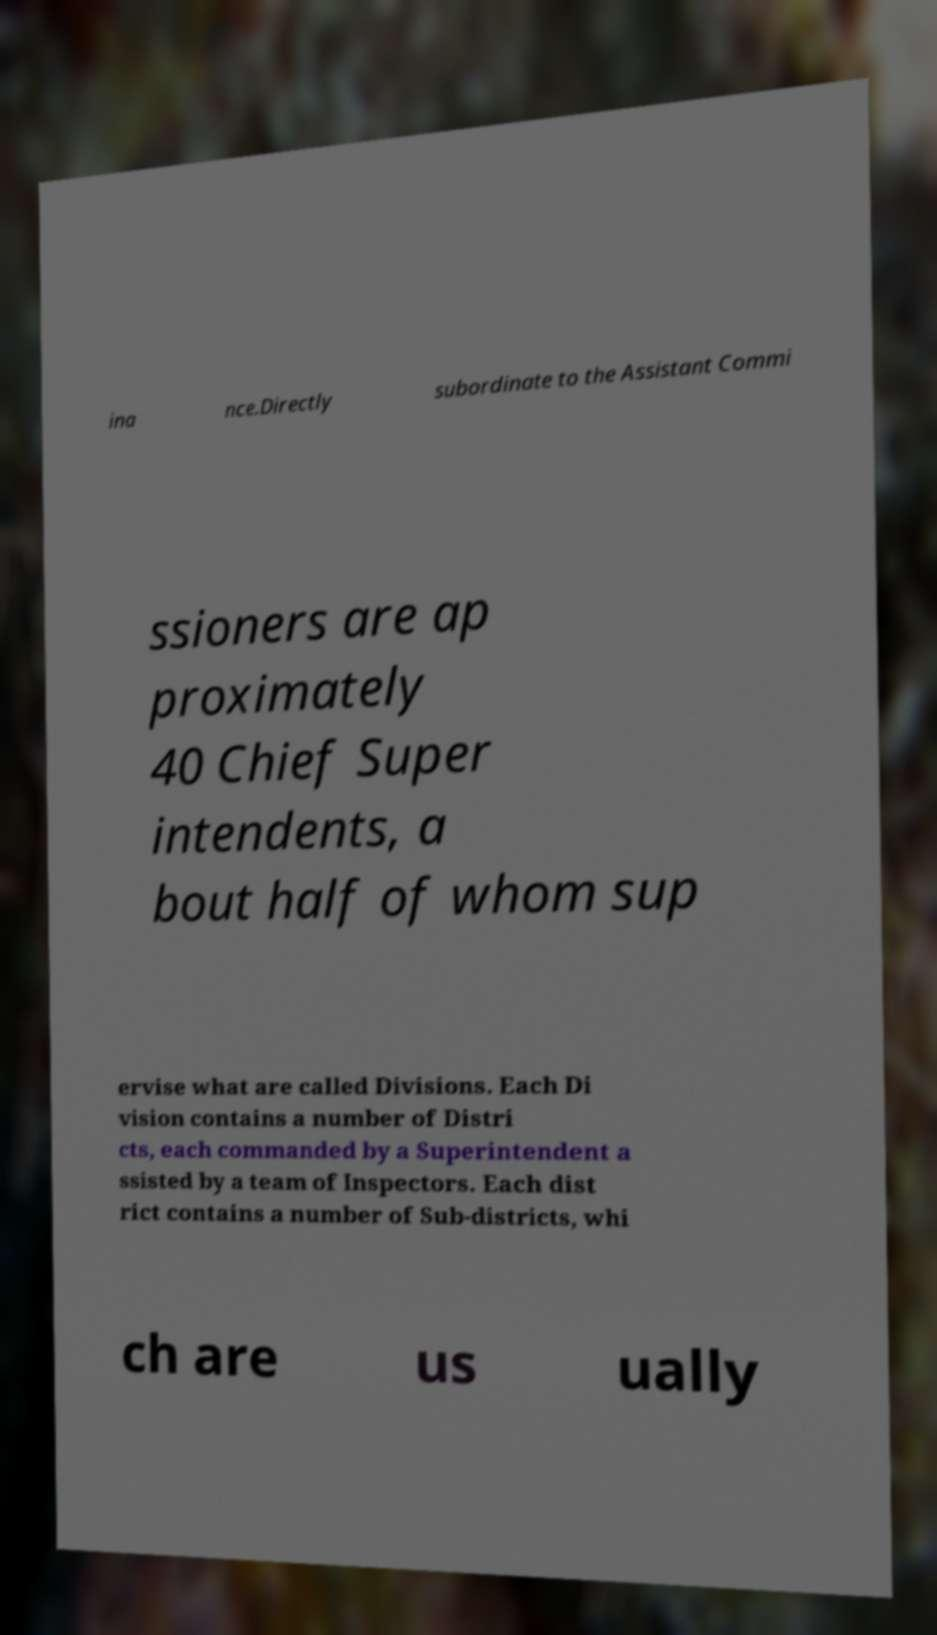There's text embedded in this image that I need extracted. Can you transcribe it verbatim? ina nce.Directly subordinate to the Assistant Commi ssioners are ap proximately 40 Chief Super intendents, a bout half of whom sup ervise what are called Divisions. Each Di vision contains a number of Distri cts, each commanded by a Superintendent a ssisted by a team of Inspectors. Each dist rict contains a number of Sub-districts, whi ch are us ually 